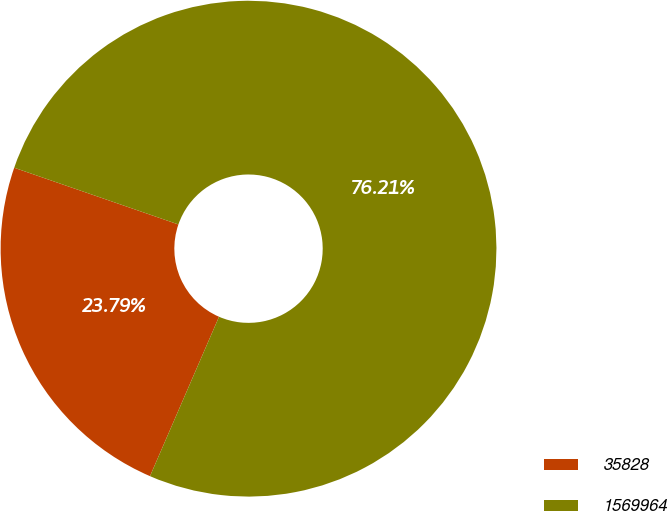<chart> <loc_0><loc_0><loc_500><loc_500><pie_chart><fcel>35828<fcel>1569964<nl><fcel>23.79%<fcel>76.21%<nl></chart> 